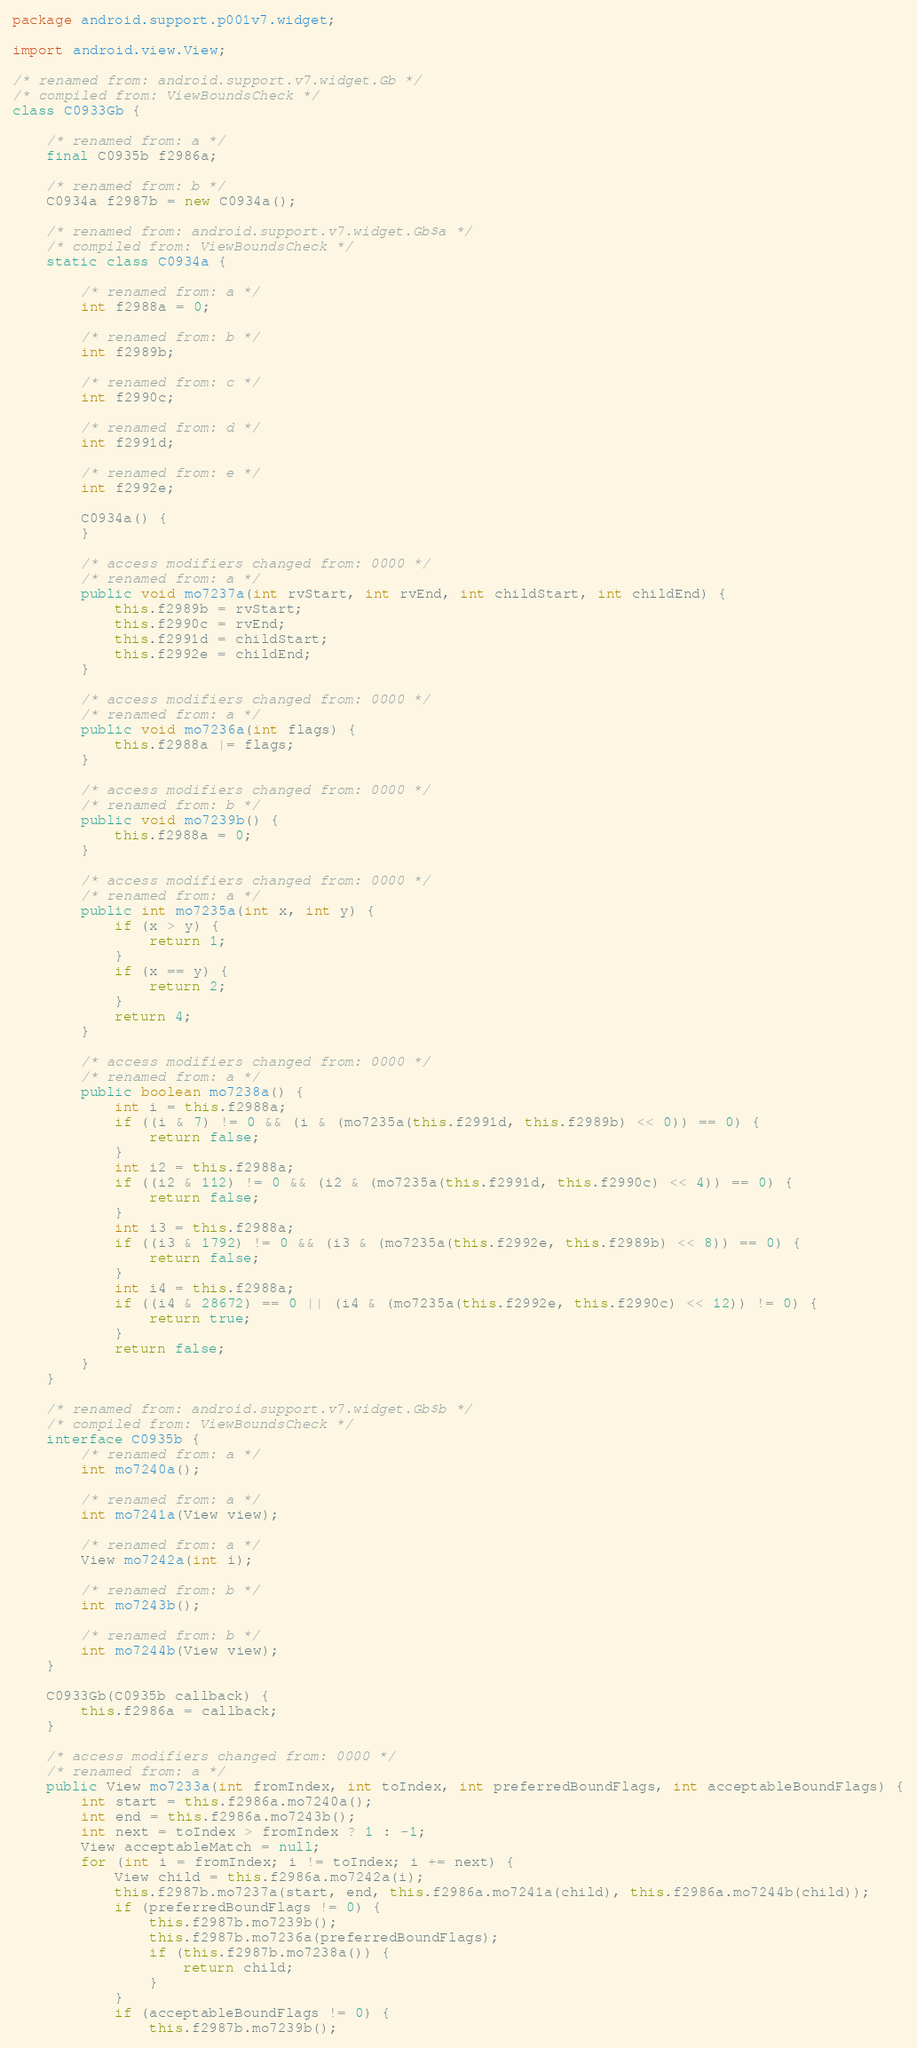<code> <loc_0><loc_0><loc_500><loc_500><_Java_>package android.support.p001v7.widget;

import android.view.View;

/* renamed from: android.support.v7.widget.Gb */
/* compiled from: ViewBoundsCheck */
class C0933Gb {

    /* renamed from: a */
    final C0935b f2986a;

    /* renamed from: b */
    C0934a f2987b = new C0934a();

    /* renamed from: android.support.v7.widget.Gb$a */
    /* compiled from: ViewBoundsCheck */
    static class C0934a {

        /* renamed from: a */
        int f2988a = 0;

        /* renamed from: b */
        int f2989b;

        /* renamed from: c */
        int f2990c;

        /* renamed from: d */
        int f2991d;

        /* renamed from: e */
        int f2992e;

        C0934a() {
        }

        /* access modifiers changed from: 0000 */
        /* renamed from: a */
        public void mo7237a(int rvStart, int rvEnd, int childStart, int childEnd) {
            this.f2989b = rvStart;
            this.f2990c = rvEnd;
            this.f2991d = childStart;
            this.f2992e = childEnd;
        }

        /* access modifiers changed from: 0000 */
        /* renamed from: a */
        public void mo7236a(int flags) {
            this.f2988a |= flags;
        }

        /* access modifiers changed from: 0000 */
        /* renamed from: b */
        public void mo7239b() {
            this.f2988a = 0;
        }

        /* access modifiers changed from: 0000 */
        /* renamed from: a */
        public int mo7235a(int x, int y) {
            if (x > y) {
                return 1;
            }
            if (x == y) {
                return 2;
            }
            return 4;
        }

        /* access modifiers changed from: 0000 */
        /* renamed from: a */
        public boolean mo7238a() {
            int i = this.f2988a;
            if ((i & 7) != 0 && (i & (mo7235a(this.f2991d, this.f2989b) << 0)) == 0) {
                return false;
            }
            int i2 = this.f2988a;
            if ((i2 & 112) != 0 && (i2 & (mo7235a(this.f2991d, this.f2990c) << 4)) == 0) {
                return false;
            }
            int i3 = this.f2988a;
            if ((i3 & 1792) != 0 && (i3 & (mo7235a(this.f2992e, this.f2989b) << 8)) == 0) {
                return false;
            }
            int i4 = this.f2988a;
            if ((i4 & 28672) == 0 || (i4 & (mo7235a(this.f2992e, this.f2990c) << 12)) != 0) {
                return true;
            }
            return false;
        }
    }

    /* renamed from: android.support.v7.widget.Gb$b */
    /* compiled from: ViewBoundsCheck */
    interface C0935b {
        /* renamed from: a */
        int mo7240a();

        /* renamed from: a */
        int mo7241a(View view);

        /* renamed from: a */
        View mo7242a(int i);

        /* renamed from: b */
        int mo7243b();

        /* renamed from: b */
        int mo7244b(View view);
    }

    C0933Gb(C0935b callback) {
        this.f2986a = callback;
    }

    /* access modifiers changed from: 0000 */
    /* renamed from: a */
    public View mo7233a(int fromIndex, int toIndex, int preferredBoundFlags, int acceptableBoundFlags) {
        int start = this.f2986a.mo7240a();
        int end = this.f2986a.mo7243b();
        int next = toIndex > fromIndex ? 1 : -1;
        View acceptableMatch = null;
        for (int i = fromIndex; i != toIndex; i += next) {
            View child = this.f2986a.mo7242a(i);
            this.f2987b.mo7237a(start, end, this.f2986a.mo7241a(child), this.f2986a.mo7244b(child));
            if (preferredBoundFlags != 0) {
                this.f2987b.mo7239b();
                this.f2987b.mo7236a(preferredBoundFlags);
                if (this.f2987b.mo7238a()) {
                    return child;
                }
            }
            if (acceptableBoundFlags != 0) {
                this.f2987b.mo7239b();</code> 